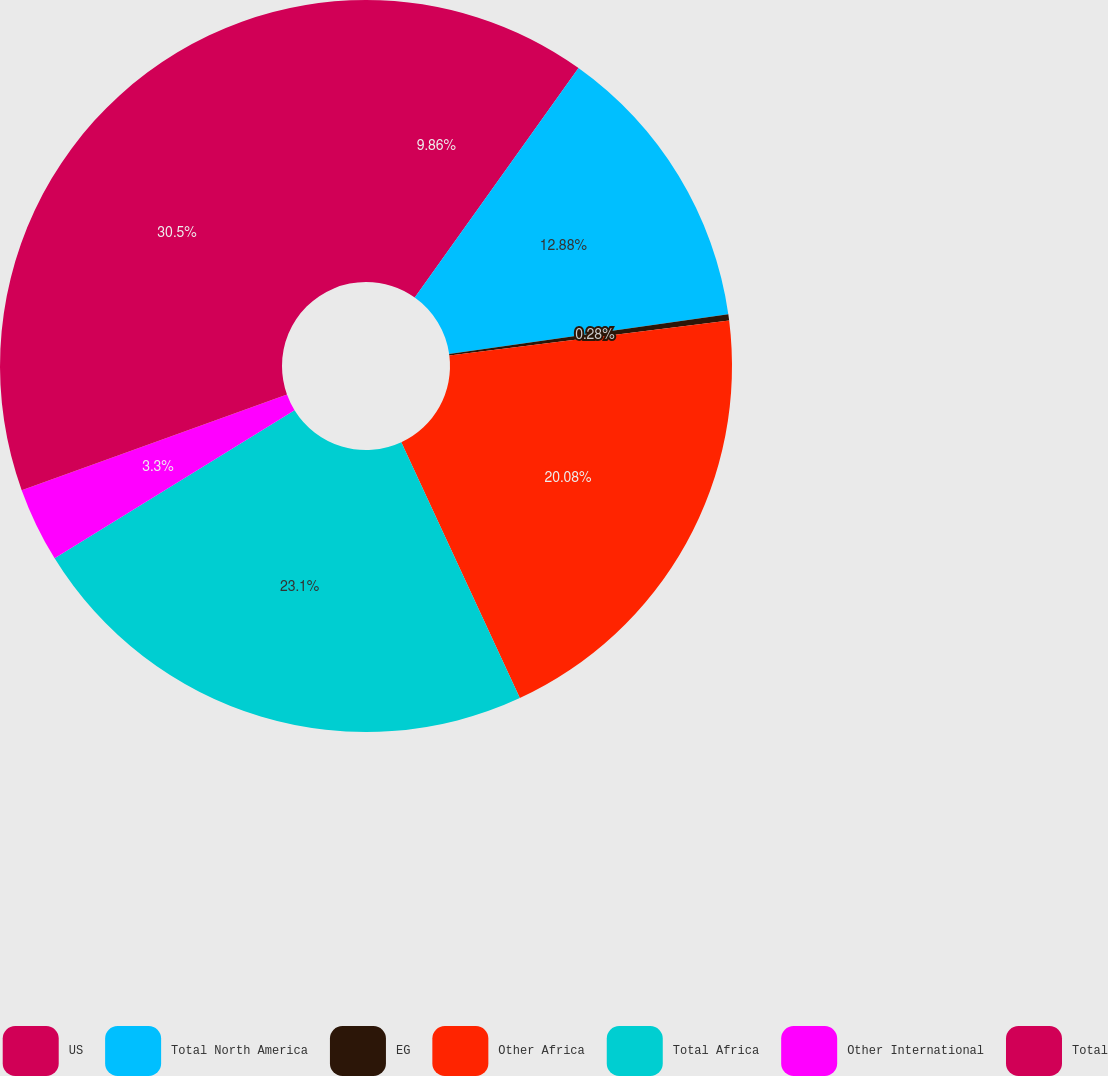Convert chart to OTSL. <chart><loc_0><loc_0><loc_500><loc_500><pie_chart><fcel>US<fcel>Total North America<fcel>EG<fcel>Other Africa<fcel>Total Africa<fcel>Other International<fcel>Total<nl><fcel>9.86%<fcel>12.88%<fcel>0.28%<fcel>20.08%<fcel>23.1%<fcel>3.3%<fcel>30.51%<nl></chart> 